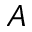<formula> <loc_0><loc_0><loc_500><loc_500>_ { A }</formula> 